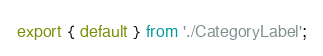<code> <loc_0><loc_0><loc_500><loc_500><_TypeScript_>export { default } from './CategoryLabel';
</code> 